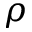<formula> <loc_0><loc_0><loc_500><loc_500>\rho</formula> 